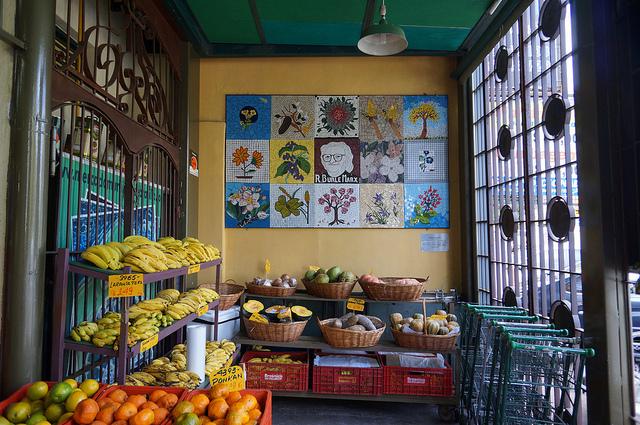How many bananas are there?
Write a very short answer. 150. What does the store sell?
Give a very brief answer. Fruit. What fruit is this?
Answer briefly. Bananas. What is the food on the shelves?
Concise answer only. Bananas. What color are the 3 baskets on the bottom shelf?
Give a very brief answer. Red. Is this a home?
Short answer required. No. What color are the closest crates?
Short answer required. Red. What is available for sale in this market?
Write a very short answer. Fruit. What does this store sell?
Concise answer only. Fruit. Where are the green apples?
Short answer required. Basket. 